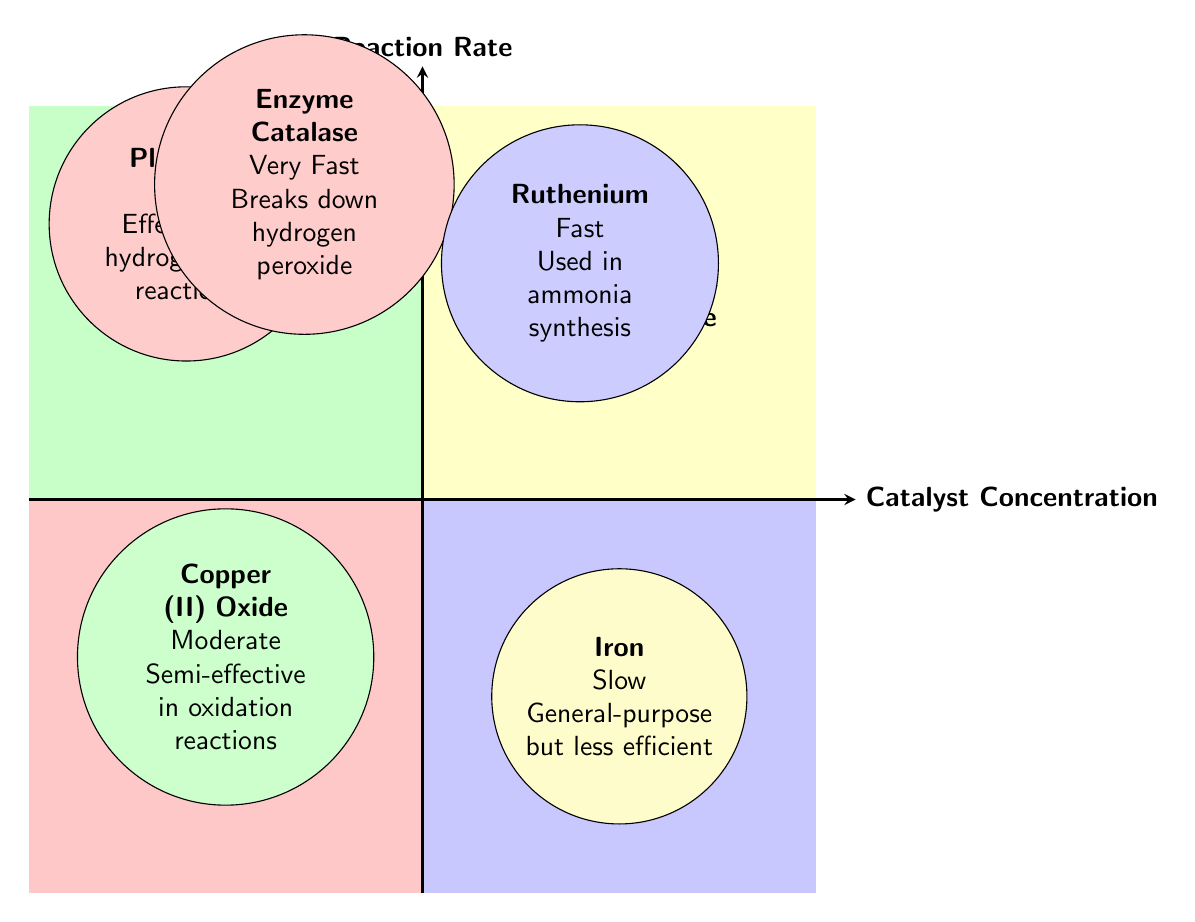What catalysts are located in the "High Concentration, High Rate" quadrant? The "High Concentration, High Rate" quadrant contains the catalysts Platinum and Enzyme Catalase, as indicated in the diagram.
Answer: Platinum, Enzyme Catalase What is the reaction rate of Iron? The diagram specifies that Iron has a reaction rate listed as "Slow," derived from its representation in the "Low Concentration, Low Rate" quadrant.
Answer: Slow Which catalyst is characterized as "Very Fast"? The diagram identifies Enzyme Catalase as "Very Fast," indicated in the description within the "High Concentration, High Rate" quadrant.
Answer: Enzyme Catalase How many catalysts are shown in the "Low Concentration, High Rate" quadrant? There is one catalyst, Ruthenium, in the "Low Concentration, High Rate" quadrant, as indicated by the diagram.
Answer: 1 Which catalyst has a moderate reaction rate and appears in the "High Concentration, Low Rate" quadrant? The diagram shows Copper (II) Oxide in the "High Concentration, Low Rate" quadrant, with a reaction rate described as "Moderate."
Answer: Copper (II) Oxide What is the relationship between concentration and reaction rate for Ruthenium? Ruthenium is located in the "Low Concentration, High Rate" quadrant, indicating that it has a high reaction rate despite having a low concentration, demonstrating an exception to common trends.
Answer: High Rate, Low Concentration Which quadrant contains catalysts that are both effective and fast? The "High Concentration, High Rate" quadrant contains catalysts that are both effective and fast, such as Platinum and Enzyme Catalase, as outlined in the diagram.
Answer: High Concentration, High Rate What can be inferred about the efficiency of Iron compared to Platinum? The diagram indicates Iron has a "Slow" reaction rate and is described as general-purpose but less efficient, whereas Platinum is "Fast" and effective, suggesting that Platinum is more efficient than Iron.
Answer: Platinum is more efficient 